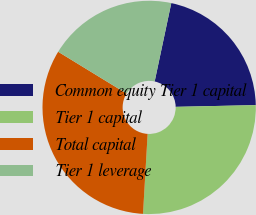Convert chart. <chart><loc_0><loc_0><loc_500><loc_500><pie_chart><fcel>Common equity Tier 1 capital<fcel>Tier 1 capital<fcel>Total capital<fcel>Tier 1 leverage<nl><fcel>21.33%<fcel>26.26%<fcel>32.82%<fcel>19.59%<nl></chart> 